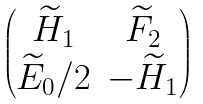<formula> <loc_0><loc_0><loc_500><loc_500>\begin{pmatrix} \widetilde { H } _ { 1 } & \widetilde { F } _ { 2 } \\ \widetilde { E } _ { 0 } / 2 & - \widetilde { H } _ { 1 } \end{pmatrix}</formula> 